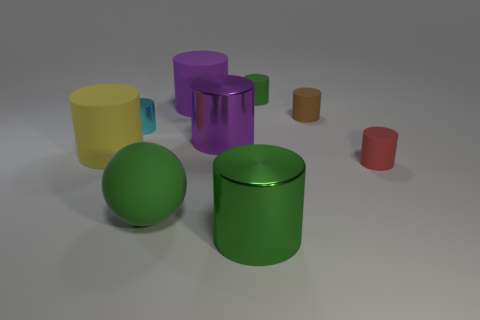Subtract all purple rubber cylinders. How many cylinders are left? 7 Subtract all purple cylinders. How many cylinders are left? 6 Subtract all cyan cylinders. Subtract all red balls. How many cylinders are left? 7 Add 1 green matte spheres. How many objects exist? 10 Subtract all cylinders. How many objects are left? 1 Add 4 purple shiny things. How many purple shiny things are left? 5 Add 2 yellow cylinders. How many yellow cylinders exist? 3 Subtract 0 yellow blocks. How many objects are left? 9 Subtract all tiny cyan metal cubes. Subtract all metallic cylinders. How many objects are left? 6 